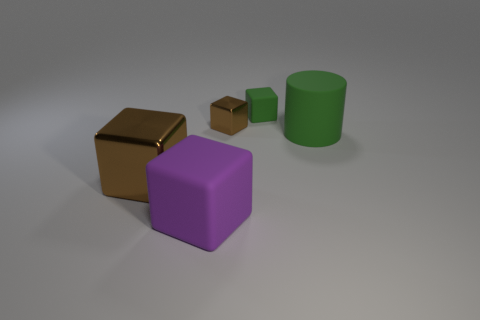Subtract all purple blocks. How many blocks are left? 3 Add 5 big matte objects. How many objects exist? 10 Subtract all cylinders. How many objects are left? 4 Subtract 1 cylinders. How many cylinders are left? 0 Subtract all cyan cylinders. How many gray cubes are left? 0 Subtract all green cylinders. Subtract all small cyan spheres. How many objects are left? 4 Add 5 big green cylinders. How many big green cylinders are left? 6 Add 2 large purple shiny cylinders. How many large purple shiny cylinders exist? 2 Subtract 0 red cylinders. How many objects are left? 5 Subtract all gray blocks. Subtract all purple cylinders. How many blocks are left? 4 